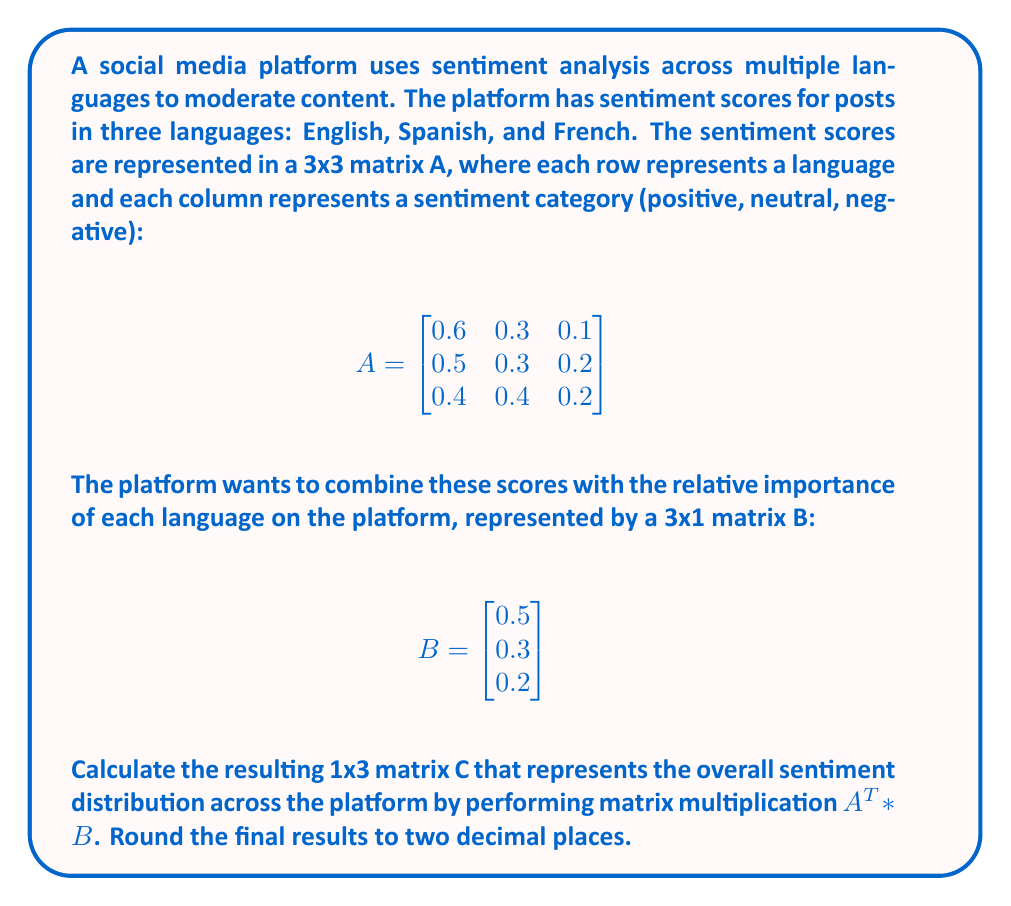Teach me how to tackle this problem. To solve this problem, we need to follow these steps:

1) First, we need to transpose matrix A. The transpose of A (A^T) is:

   $$ A^T = \begin{bmatrix}
   0.6 & 0.5 & 0.4 \\
   0.3 & 0.3 & 0.4 \\
   0.1 & 0.2 & 0.2
   \end{bmatrix} $$

2) Now, we need to multiply A^T (3x3) by B (3x1). The resulting matrix C will be 3x1.

3) The formula for matrix multiplication is:
   $C_{ij} = \sum_{k=1}^n A^T_{ik} \cdot B_{kj}$

4) Let's calculate each element of C:

   $C_{11} = (0.6 \cdot 0.5) + (0.5 \cdot 0.3) + (0.4 \cdot 0.2) = 0.3 + 0.15 + 0.08 = 0.53$

   $C_{21} = (0.3 \cdot 0.5) + (0.3 \cdot 0.3) + (0.4 \cdot 0.2) = 0.15 + 0.09 + 0.08 = 0.32$

   $C_{31} = (0.1 \cdot 0.5) + (0.2 \cdot 0.3) + (0.2 \cdot 0.2) = 0.05 + 0.06 + 0.04 = 0.15$

5) Rounding to two decimal places, our final matrix C is:

   $$ C = \begin{bmatrix}
   0.53 \\
   0.32 \\
   0.15
   \end{bmatrix} $$

This result represents the overall sentiment distribution (positive, neutral, negative) across the platform, taking into account the importance of each language.
Answer: $$ C = \begin{bmatrix}
0.53 \\
0.32 \\
0.15
\end{bmatrix} $$ 